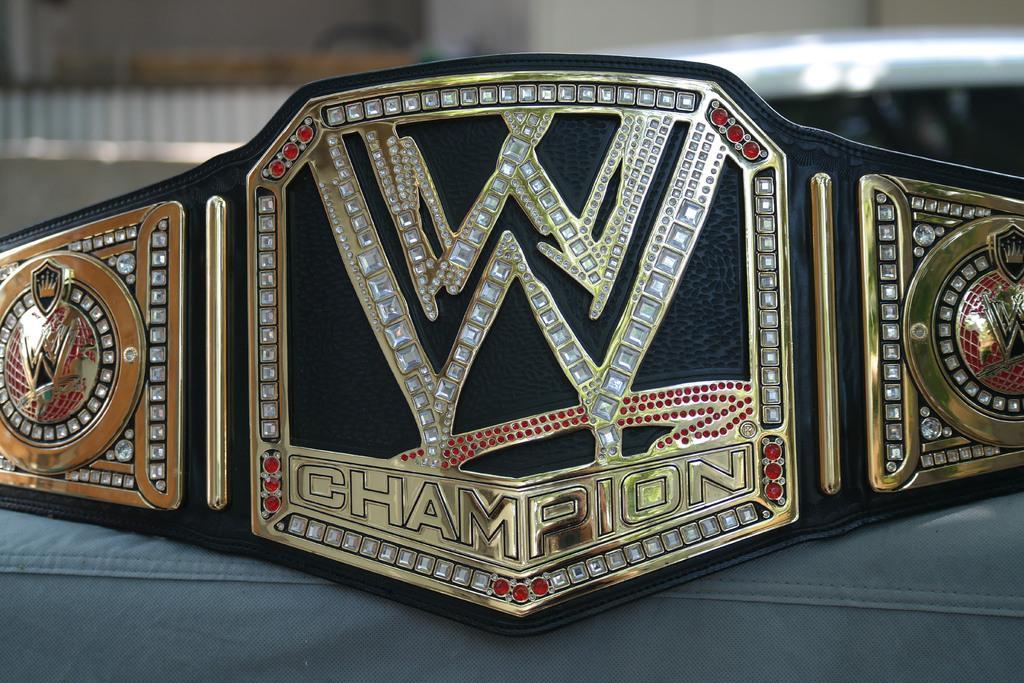How would you summarize this image in a sentence or two? In this image I can see the belt and the belt is in black and gold color and I can see the blurred background. 